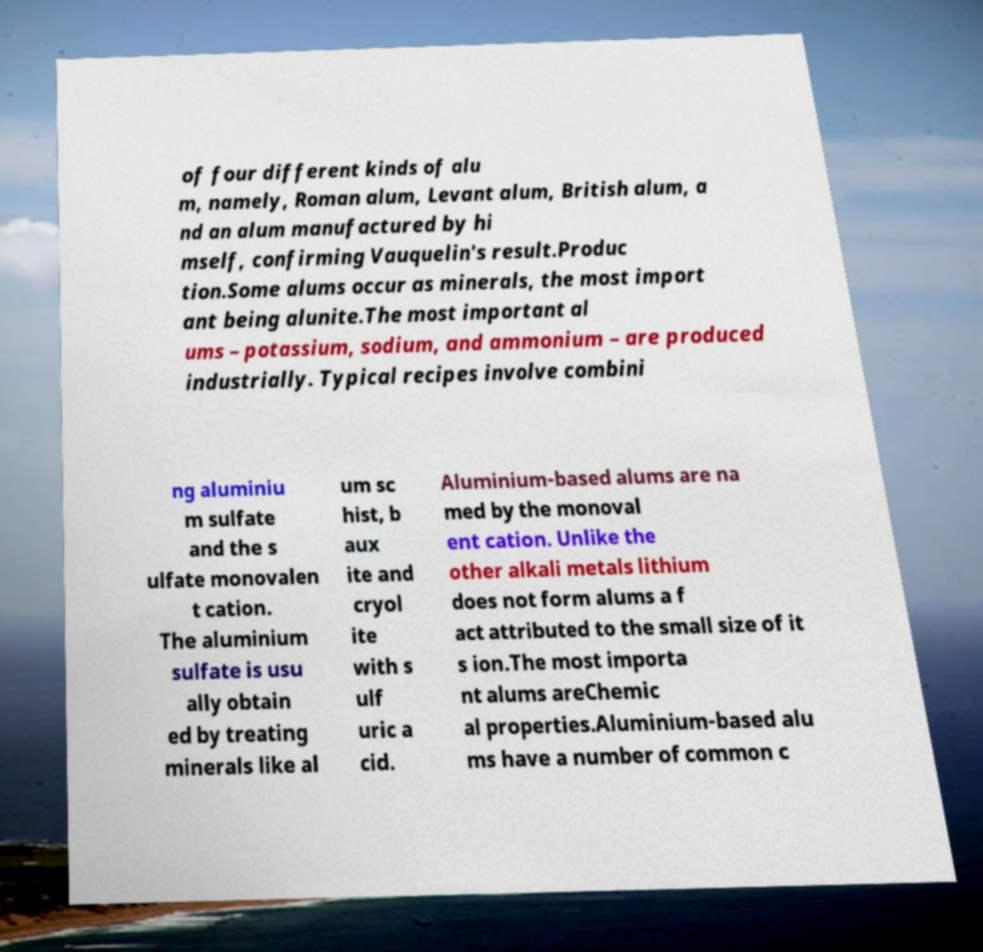Can you accurately transcribe the text from the provided image for me? of four different kinds of alu m, namely, Roman alum, Levant alum, British alum, a nd an alum manufactured by hi mself, confirming Vauquelin's result.Produc tion.Some alums occur as minerals, the most import ant being alunite.The most important al ums – potassium, sodium, and ammonium – are produced industrially. Typical recipes involve combini ng aluminiu m sulfate and the s ulfate monovalen t cation. The aluminium sulfate is usu ally obtain ed by treating minerals like al um sc hist, b aux ite and cryol ite with s ulf uric a cid. Aluminium-based alums are na med by the monoval ent cation. Unlike the other alkali metals lithium does not form alums a f act attributed to the small size of it s ion.The most importa nt alums areChemic al properties.Aluminium-based alu ms have a number of common c 